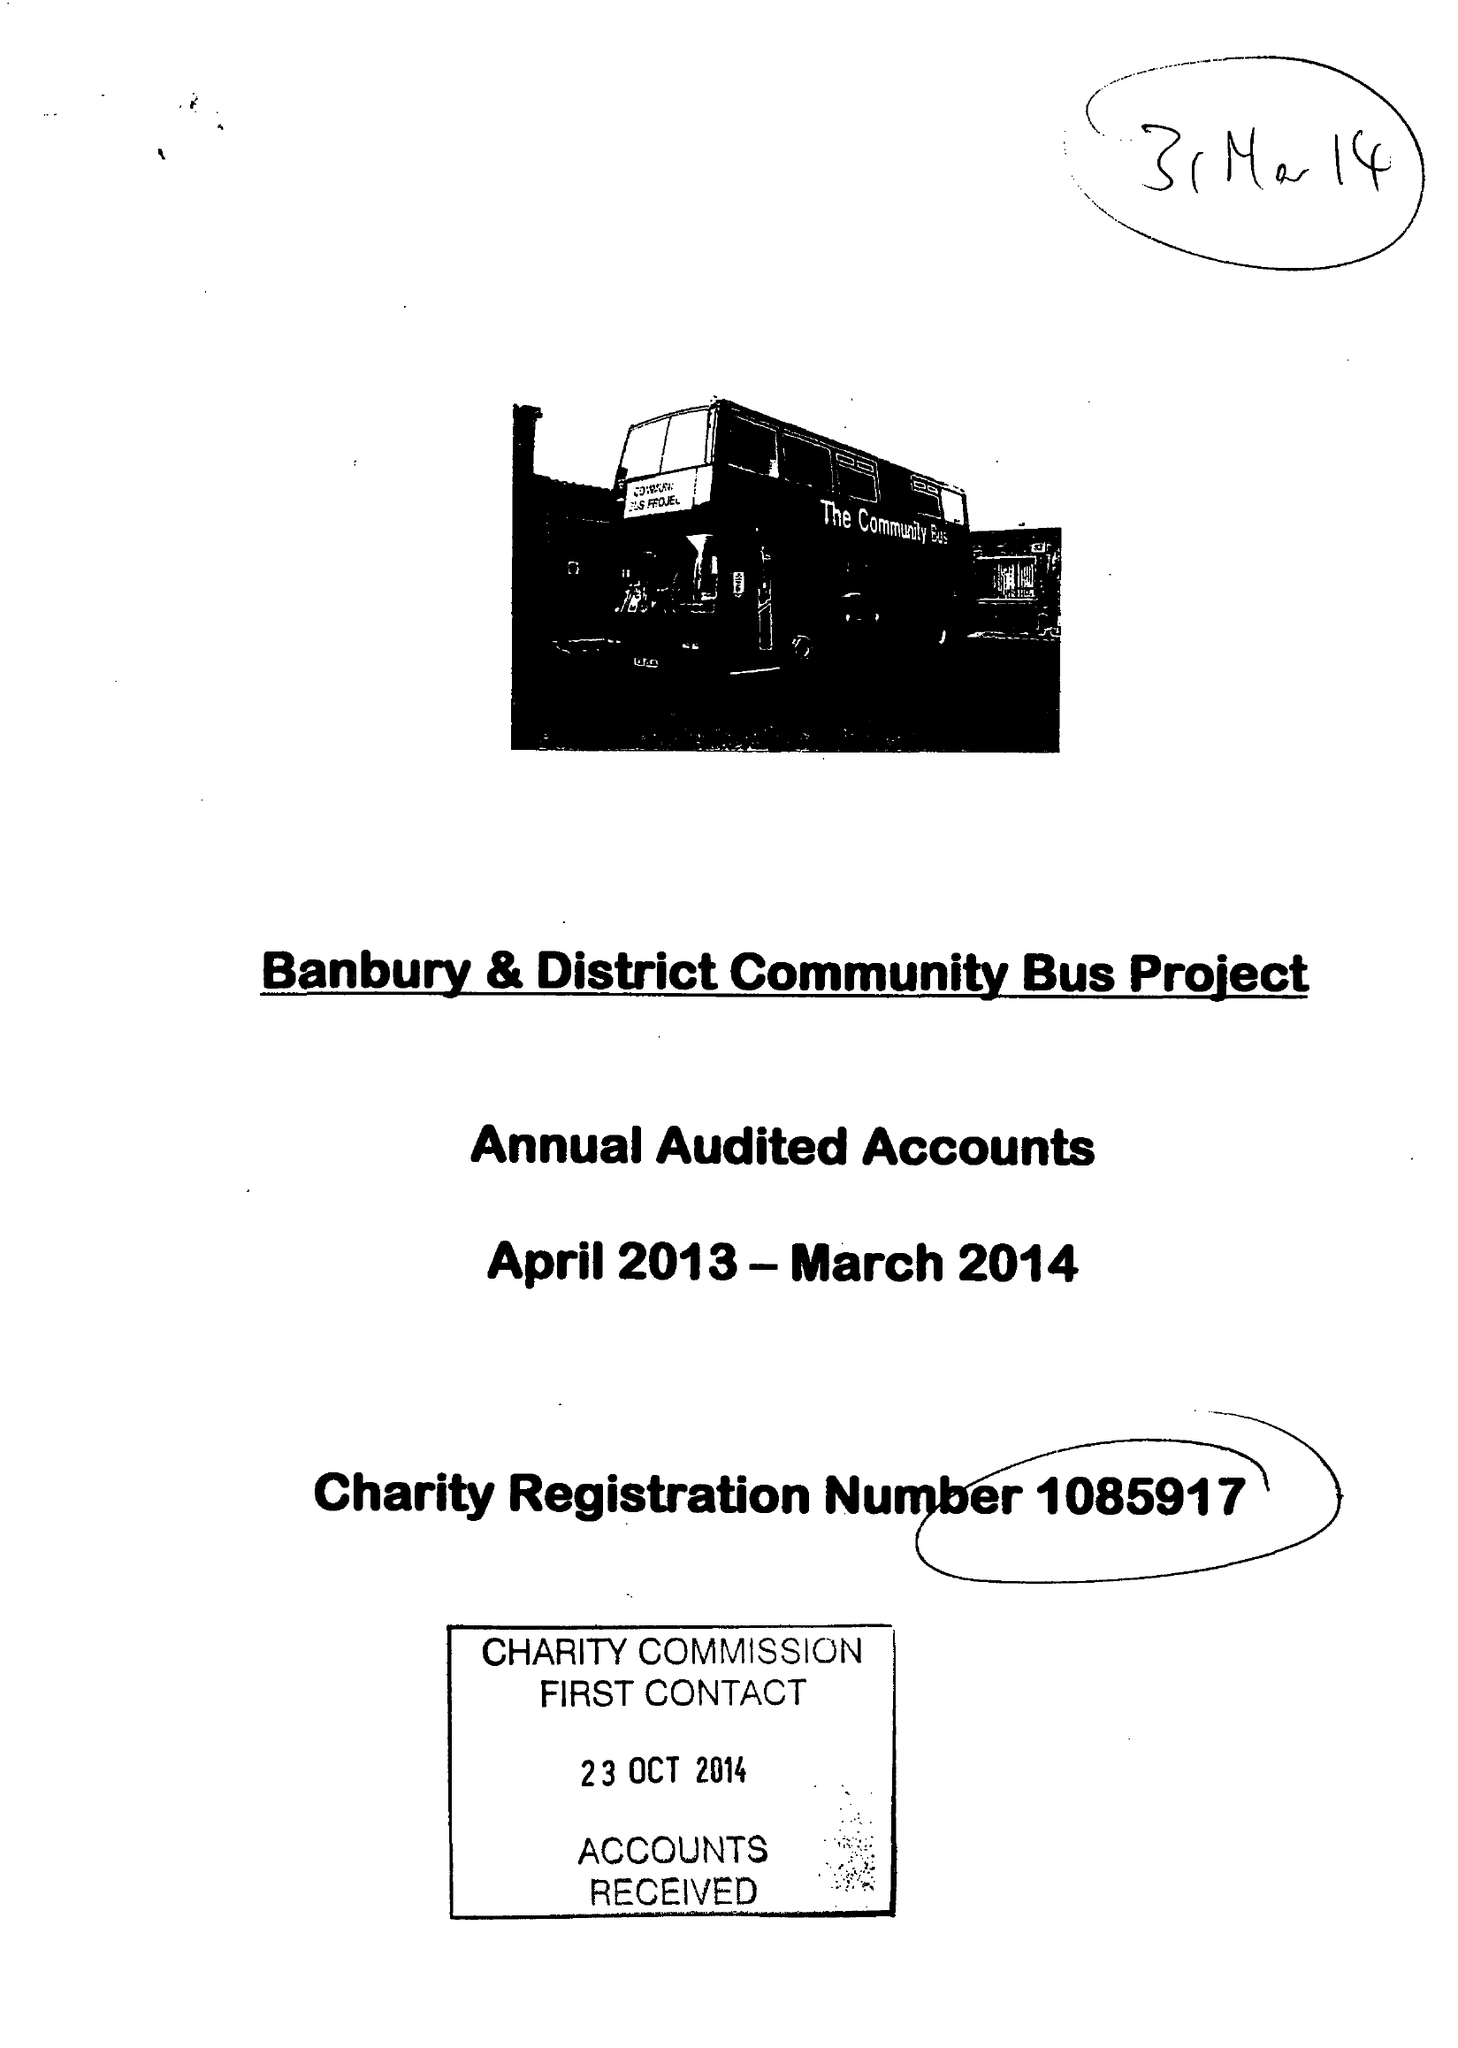What is the value for the spending_annually_in_british_pounds?
Answer the question using a single word or phrase. 138199.00 